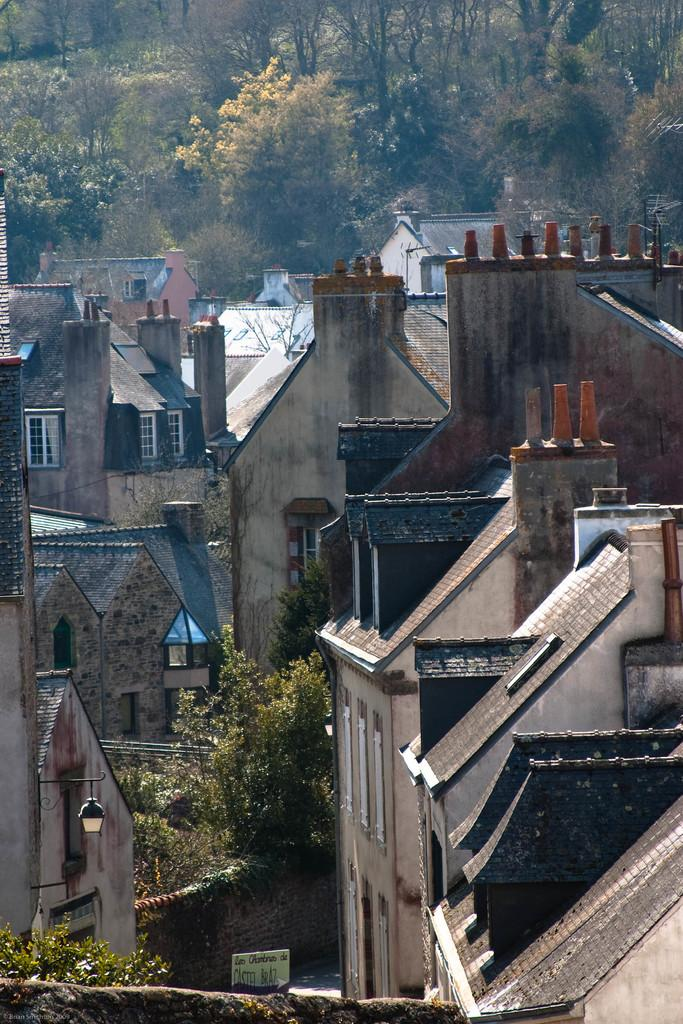What type of natural elements can be seen in the image? There are trees in the image. What type of man-made structures are visible in the image? There are buildings visible in the image. What type of wine is being served in the image? There is no wine present in the image; it only features trees and buildings. How many books can be seen on the shelves in the image? There are no shelves or books visible in the image. 